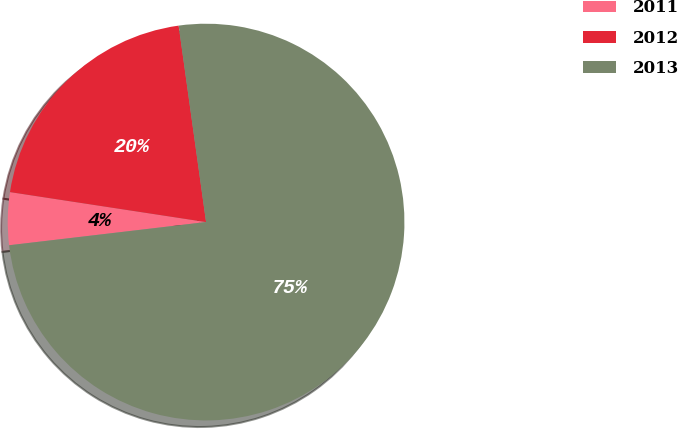Convert chart. <chart><loc_0><loc_0><loc_500><loc_500><pie_chart><fcel>2011<fcel>2012<fcel>2013<nl><fcel>4.28%<fcel>20.38%<fcel>75.34%<nl></chart> 